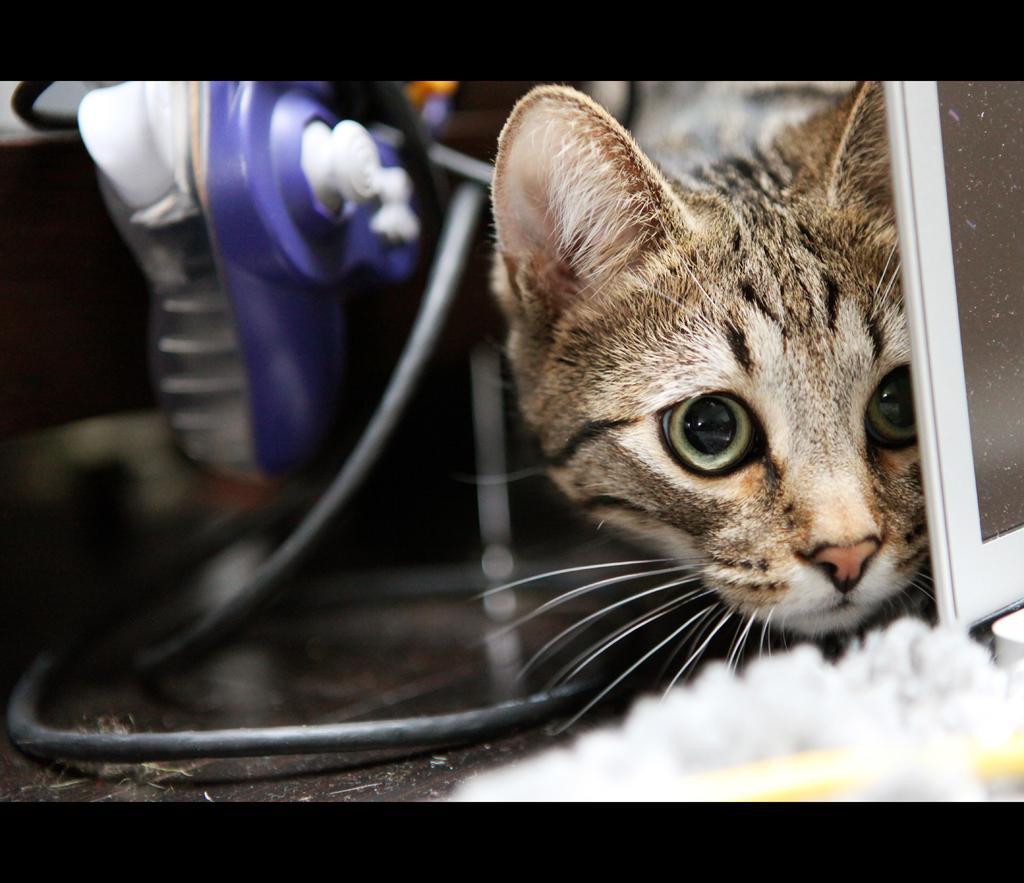Please provide a concise description of this image. In this image we can see a cat. We can also see a wire and a device beside it. 